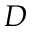<formula> <loc_0><loc_0><loc_500><loc_500>D</formula> 